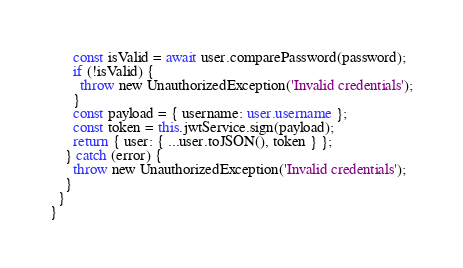Convert code to text. <code><loc_0><loc_0><loc_500><loc_500><_TypeScript_>      const isValid = await user.comparePassword(password);
      if (!isValid) {
        throw new UnauthorizedException('Invalid credentials');
      }
      const payload = { username: user.username };
      const token = this.jwtService.sign(payload);
      return { user: { ...user.toJSON(), token } };
    } catch (error) {
      throw new UnauthorizedException('Invalid credentials');
    }
  }
}
</code> 